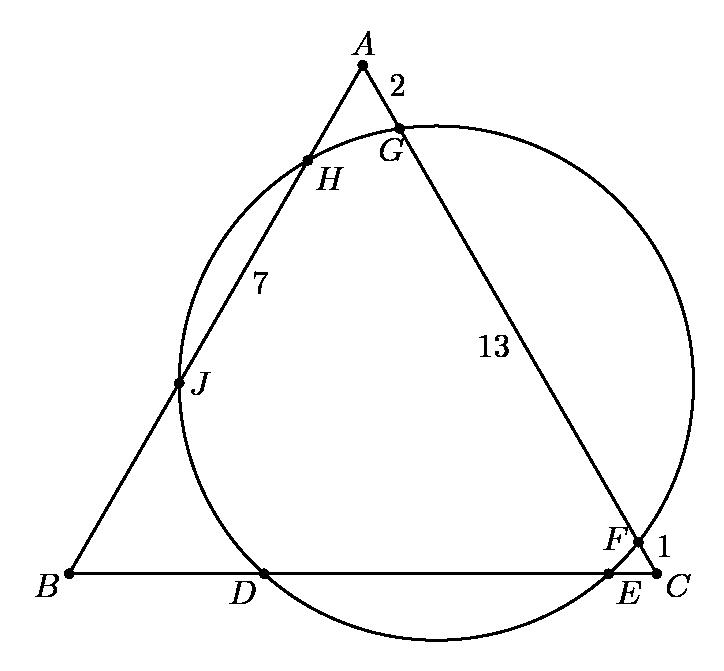How can the properties of the circle and the equilateral triangle help in finding the lengths of different segments not directly given in the diagram, such as $DE$? In an equilateral triangle inscribed in a circle, certain symmetrical properties and uniform angles can be used. Each side of the triangle likely subtends the same angle at the center, which affects how chords and other lines interact within the circle. For segments like $DE$, methods such as using central and inscribed angles, or possibly the Extended Law of Sines, could be key. Analyzing these can lead to an understanding of the relationships between the sides and the segments intersected by the circle. 